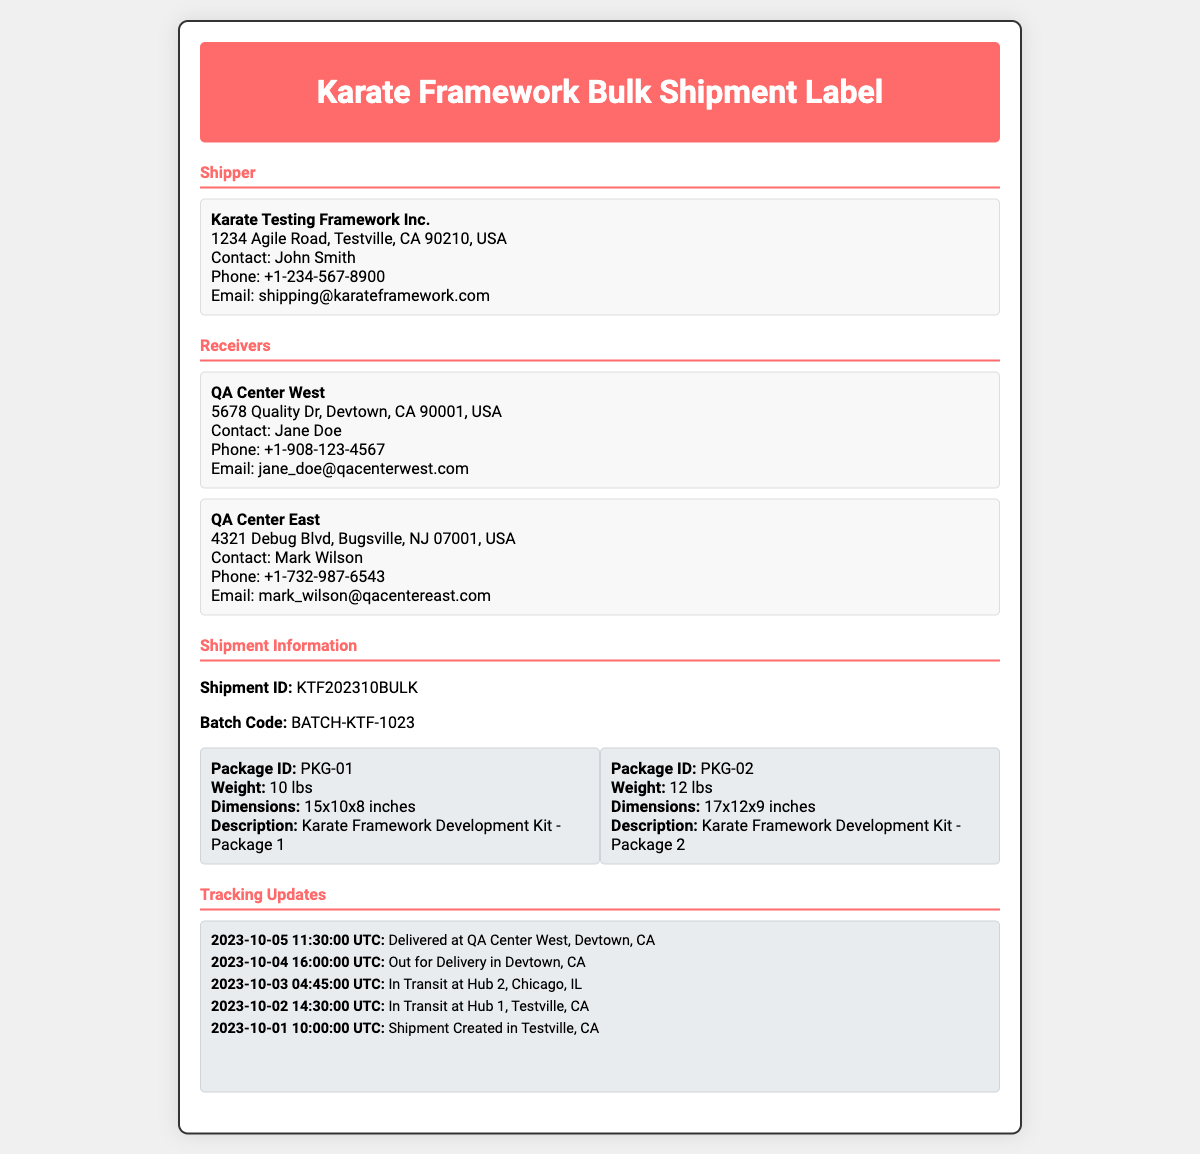What is the Shipment ID? The Shipment ID is listed under Shipment Information in the document.
Answer: KTF202310BULK Who is the contact person for the shipper? The contact person for the shipper is provided in the address section designated for the shipper.
Answer: John Smith What are the weights of the packages? The weights can be found in the package information section of the document.
Answer: 10 lbs and 12 lbs What is the Batch Code? The Batch Code is specified in the Shipment Information area.
Answer: BATCH-KTF-1023 When was the shipment delivered? The delivery date is presented in the tracking updates section, indicating the timing of delivery.
Answer: 2023-10-05 Which QA center received the shipment? The receivers listed indicate where the shipment was sent, detailing the specific center.
Answer: QA Center West How many packages are included in this shipment? The number of packages is determined by counting the package listed in the package info section.
Answer: 2 What is the email address for contacting the shipper? The email address is included in the address section for the shipper.
Answer: shipping@karateframework.com What is the description of Package 1? The description for Package 1 is found in the package information section.
Answer: Karate Framework Development Kit - Package 1 